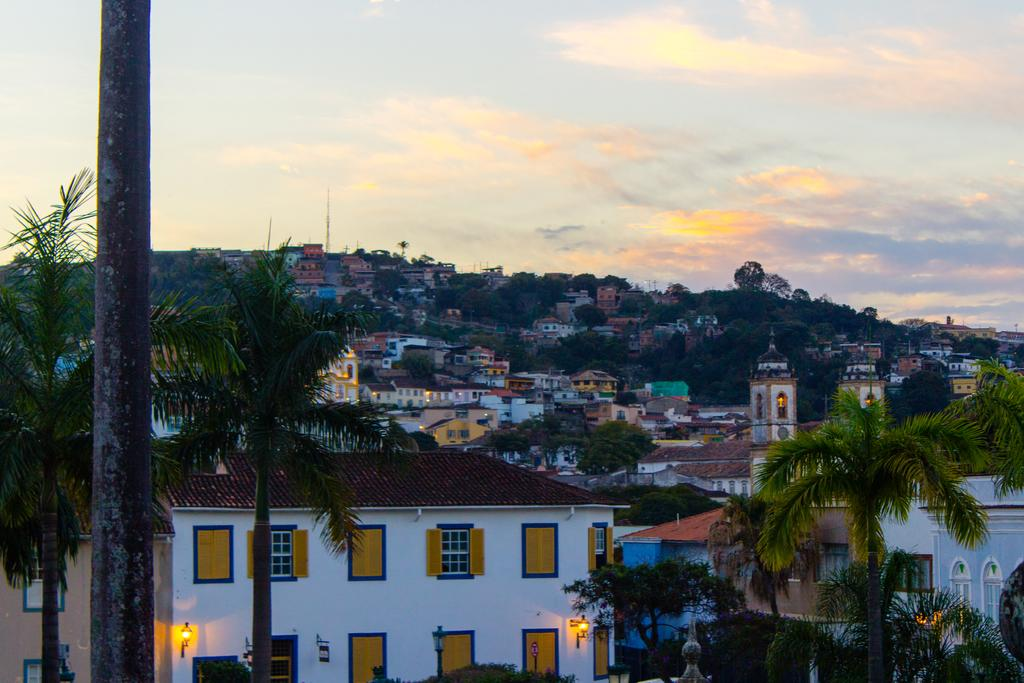What type of structures can be seen in the image? There are many houses and buildings in the image. What type of vegetation is present in the image? There are trees in the image. Where is the pole located in the image? The pole is on the left side of the image. What is visible at the top of the image? There are clouds visible at the top of the image. What type of prison can be seen in the image? There is no prison present in the image. What is the moon's position in the image? The moon is not visible in the image; only clouds are present at the top of the image. 